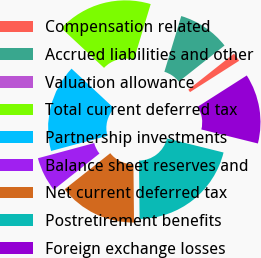Convert chart. <chart><loc_0><loc_0><loc_500><loc_500><pie_chart><fcel>Compensation related<fcel>Accrued liabilities and other<fcel>Valuation allowance<fcel>Total current deferred tax<fcel>Partnership investments<fcel>Balance sheet reserves and<fcel>Net current deferred tax<fcel>Postretirement benefits<fcel>Foreign exchange losses<nl><fcel>1.61%<fcel>9.68%<fcel>0.0%<fcel>17.74%<fcel>16.13%<fcel>6.45%<fcel>14.52%<fcel>20.97%<fcel>12.9%<nl></chart> 